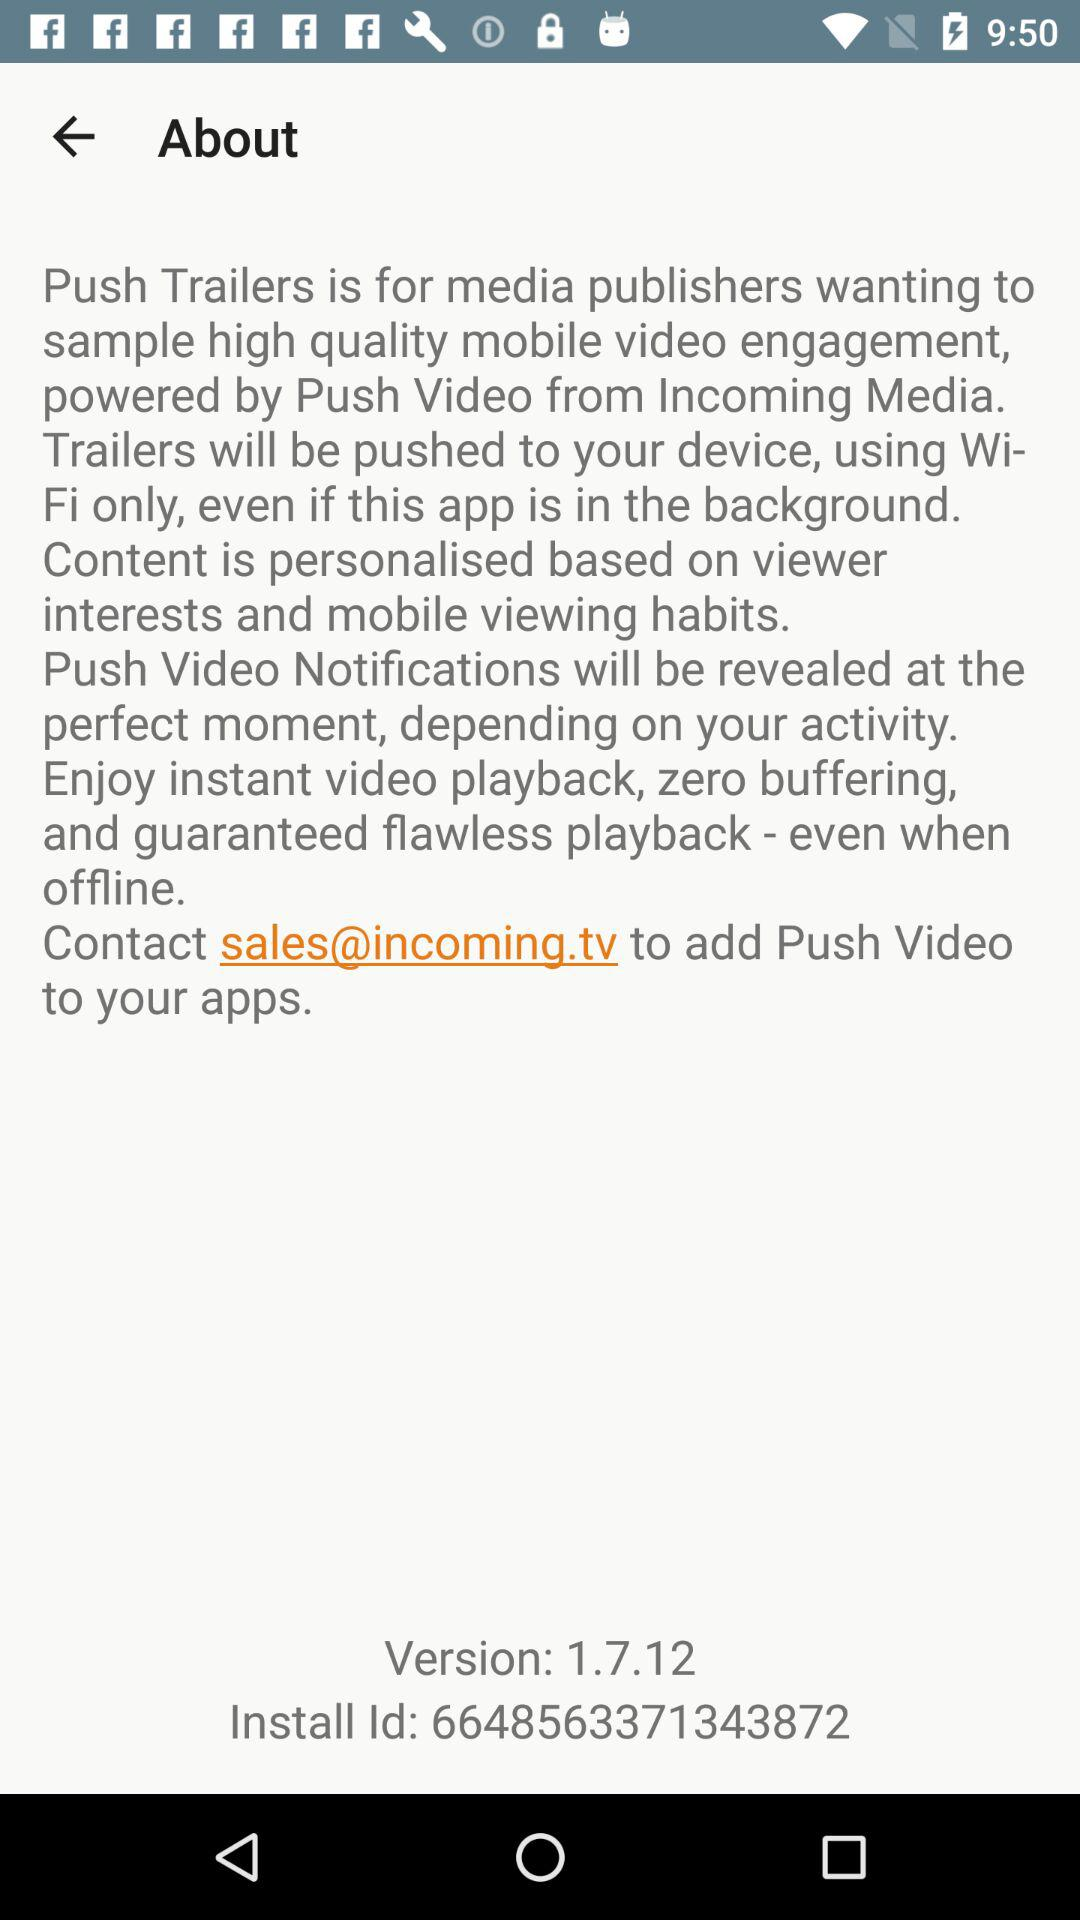What is the version? The version is "1.7.12". 